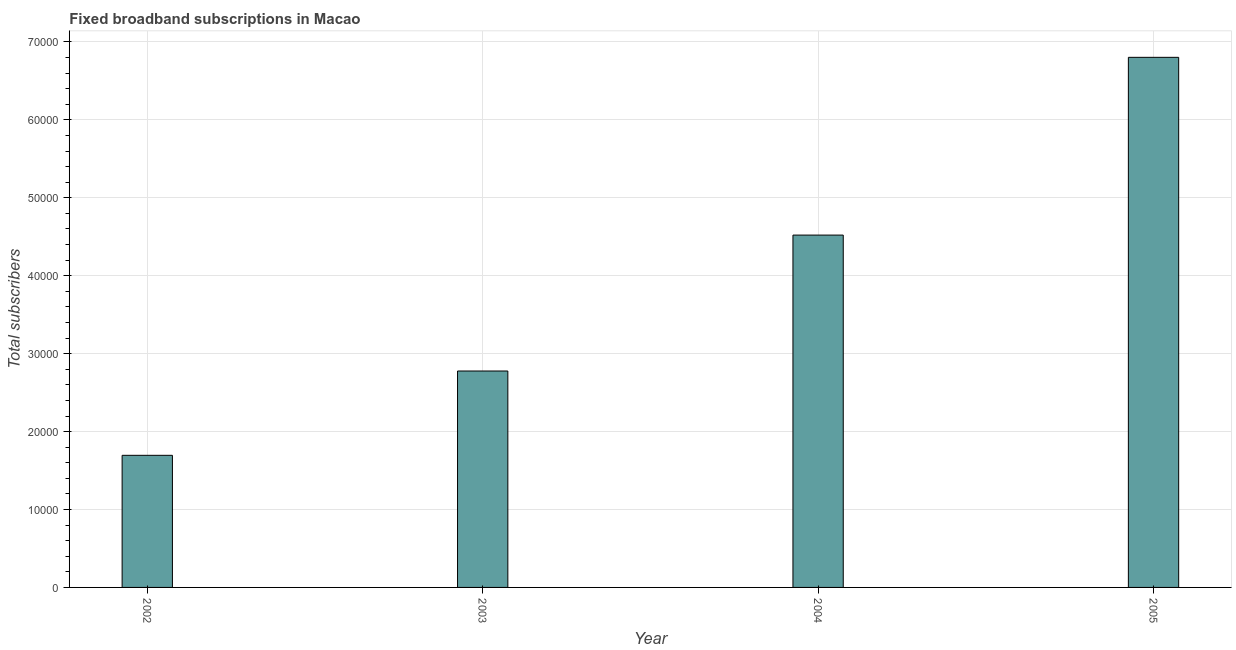Does the graph contain grids?
Offer a very short reply. Yes. What is the title of the graph?
Provide a short and direct response. Fixed broadband subscriptions in Macao. What is the label or title of the Y-axis?
Give a very brief answer. Total subscribers. What is the total number of fixed broadband subscriptions in 2005?
Your answer should be very brief. 6.80e+04. Across all years, what is the maximum total number of fixed broadband subscriptions?
Your answer should be very brief. 6.80e+04. Across all years, what is the minimum total number of fixed broadband subscriptions?
Provide a succinct answer. 1.70e+04. In which year was the total number of fixed broadband subscriptions minimum?
Offer a very short reply. 2002. What is the sum of the total number of fixed broadband subscriptions?
Your answer should be compact. 1.58e+05. What is the difference between the total number of fixed broadband subscriptions in 2003 and 2005?
Offer a terse response. -4.03e+04. What is the average total number of fixed broadband subscriptions per year?
Make the answer very short. 3.95e+04. What is the median total number of fixed broadband subscriptions?
Give a very brief answer. 3.65e+04. In how many years, is the total number of fixed broadband subscriptions greater than 66000 ?
Give a very brief answer. 1. What is the ratio of the total number of fixed broadband subscriptions in 2002 to that in 2003?
Offer a terse response. 0.61. Is the difference between the total number of fixed broadband subscriptions in 2002 and 2003 greater than the difference between any two years?
Make the answer very short. No. What is the difference between the highest and the second highest total number of fixed broadband subscriptions?
Your answer should be compact. 2.28e+04. Is the sum of the total number of fixed broadband subscriptions in 2002 and 2004 greater than the maximum total number of fixed broadband subscriptions across all years?
Offer a terse response. No. What is the difference between the highest and the lowest total number of fixed broadband subscriptions?
Offer a very short reply. 5.11e+04. What is the difference between two consecutive major ticks on the Y-axis?
Provide a short and direct response. 10000. What is the Total subscribers in 2002?
Your response must be concise. 1.70e+04. What is the Total subscribers in 2003?
Your answer should be compact. 2.78e+04. What is the Total subscribers in 2004?
Your answer should be compact. 4.52e+04. What is the Total subscribers of 2005?
Provide a succinct answer. 6.80e+04. What is the difference between the Total subscribers in 2002 and 2003?
Make the answer very short. -1.08e+04. What is the difference between the Total subscribers in 2002 and 2004?
Your answer should be very brief. -2.83e+04. What is the difference between the Total subscribers in 2002 and 2005?
Your answer should be very brief. -5.11e+04. What is the difference between the Total subscribers in 2003 and 2004?
Ensure brevity in your answer.  -1.74e+04. What is the difference between the Total subscribers in 2003 and 2005?
Your answer should be very brief. -4.03e+04. What is the difference between the Total subscribers in 2004 and 2005?
Keep it short and to the point. -2.28e+04. What is the ratio of the Total subscribers in 2002 to that in 2003?
Your answer should be compact. 0.61. What is the ratio of the Total subscribers in 2002 to that in 2005?
Give a very brief answer. 0.25. What is the ratio of the Total subscribers in 2003 to that in 2004?
Offer a very short reply. 0.61. What is the ratio of the Total subscribers in 2003 to that in 2005?
Offer a very short reply. 0.41. What is the ratio of the Total subscribers in 2004 to that in 2005?
Keep it short and to the point. 0.67. 